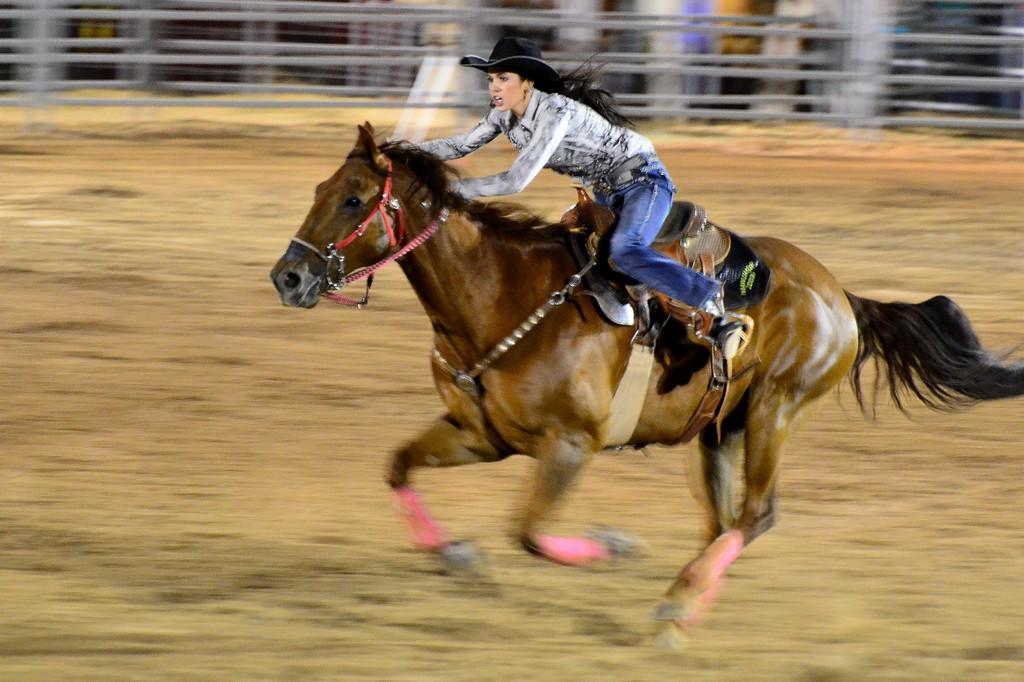Who is the main subject in the image? There is a woman in the image. What is the woman doing in the image? The woman is sitting on a horse. What is the woman wearing on her head? The woman is wearing a black color cap. What type of sidewalk can be seen in the image? There is no sidewalk present in the image. What kind of camp is the woman attending in the image? There is no camp or any indication of an event in the image. 